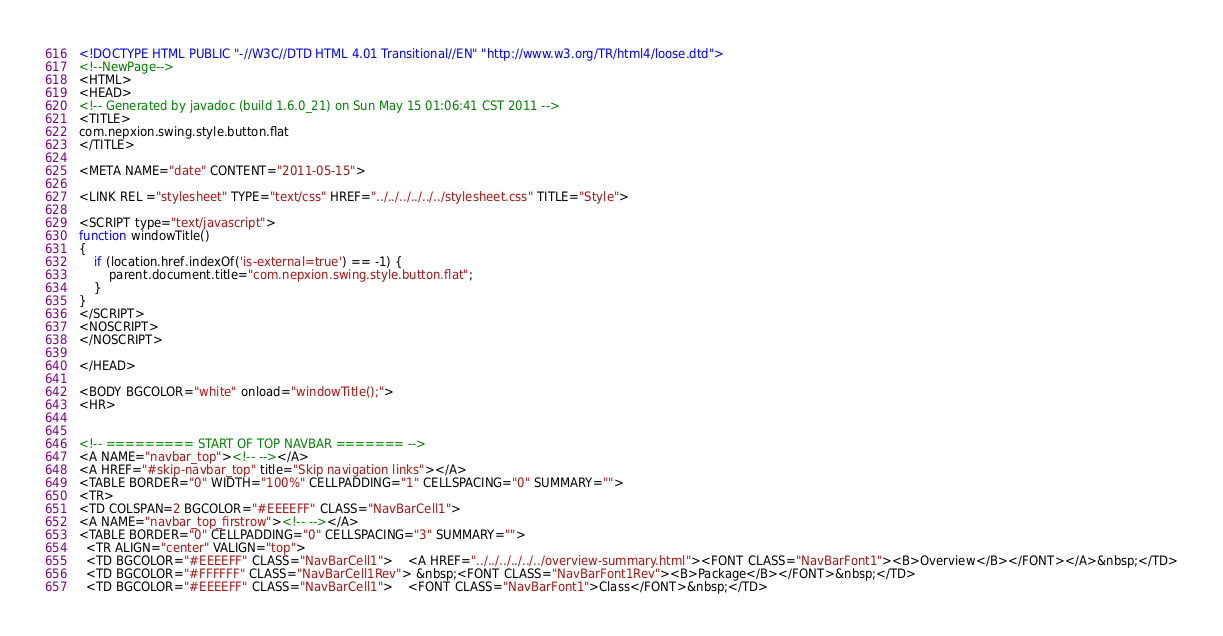<code> <loc_0><loc_0><loc_500><loc_500><_HTML_><!DOCTYPE HTML PUBLIC "-//W3C//DTD HTML 4.01 Transitional//EN" "http://www.w3.org/TR/html4/loose.dtd">
<!--NewPage-->
<HTML>
<HEAD>
<!-- Generated by javadoc (build 1.6.0_21) on Sun May 15 01:06:41 CST 2011 -->
<TITLE>
com.nepxion.swing.style.button.flat
</TITLE>

<META NAME="date" CONTENT="2011-05-15">

<LINK REL ="stylesheet" TYPE="text/css" HREF="../../../../../../stylesheet.css" TITLE="Style">

<SCRIPT type="text/javascript">
function windowTitle()
{
    if (location.href.indexOf('is-external=true') == -1) {
        parent.document.title="com.nepxion.swing.style.button.flat";
    }
}
</SCRIPT>
<NOSCRIPT>
</NOSCRIPT>

</HEAD>

<BODY BGCOLOR="white" onload="windowTitle();">
<HR>


<!-- ========= START OF TOP NAVBAR ======= -->
<A NAME="navbar_top"><!-- --></A>
<A HREF="#skip-navbar_top" title="Skip navigation links"></A>
<TABLE BORDER="0" WIDTH="100%" CELLPADDING="1" CELLSPACING="0" SUMMARY="">
<TR>
<TD COLSPAN=2 BGCOLOR="#EEEEFF" CLASS="NavBarCell1">
<A NAME="navbar_top_firstrow"><!-- --></A>
<TABLE BORDER="0" CELLPADDING="0" CELLSPACING="3" SUMMARY="">
  <TR ALIGN="center" VALIGN="top">
  <TD BGCOLOR="#EEEEFF" CLASS="NavBarCell1">    <A HREF="../../../../../../overview-summary.html"><FONT CLASS="NavBarFont1"><B>Overview</B></FONT></A>&nbsp;</TD>
  <TD BGCOLOR="#FFFFFF" CLASS="NavBarCell1Rev"> &nbsp;<FONT CLASS="NavBarFont1Rev"><B>Package</B></FONT>&nbsp;</TD>
  <TD BGCOLOR="#EEEEFF" CLASS="NavBarCell1">    <FONT CLASS="NavBarFont1">Class</FONT>&nbsp;</TD></code> 